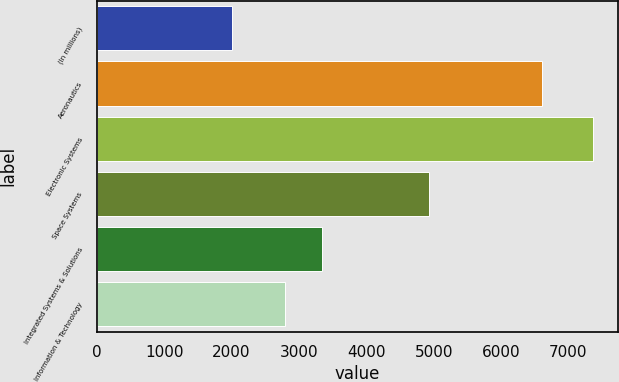<chart> <loc_0><loc_0><loc_500><loc_500><bar_chart><fcel>(In millions)<fcel>Aeronautics<fcel>Electronic Systems<fcel>Space Systems<fcel>Integrated Systems & Solutions<fcel>Information & Technology<nl><fcel>2003<fcel>6613<fcel>7363<fcel>4928<fcel>3335<fcel>2799<nl></chart> 